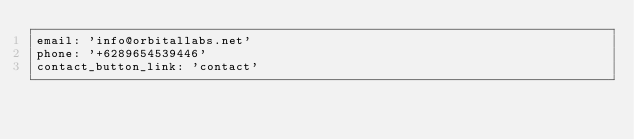Convert code to text. <code><loc_0><loc_0><loc_500><loc_500><_YAML_>email: 'info@orbitallabs.net'
phone: '+6289654539446'
contact_button_link: 'contact'
</code> 